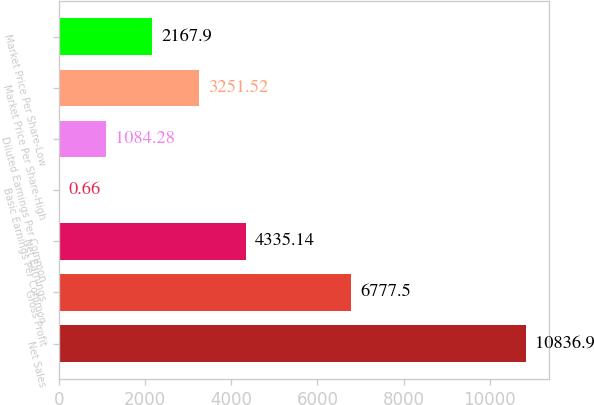Convert chart. <chart><loc_0><loc_0><loc_500><loc_500><bar_chart><fcel>Net Sales<fcel>Gross Profit<fcel>Net Earnings<fcel>Basic Earnings Per Common<fcel>Diluted Earnings Per Common<fcel>Market Price Per Share-High<fcel>Market Price Per Share-Low<nl><fcel>10836.9<fcel>6777.5<fcel>4335.14<fcel>0.66<fcel>1084.28<fcel>3251.52<fcel>2167.9<nl></chart> 